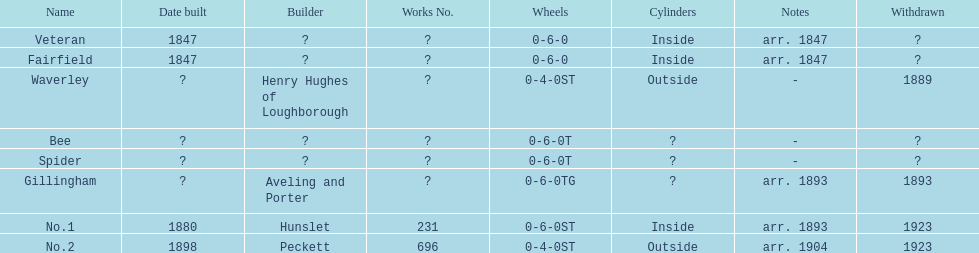Did fairfield or waverley have inside cylinders? Fairfield. 